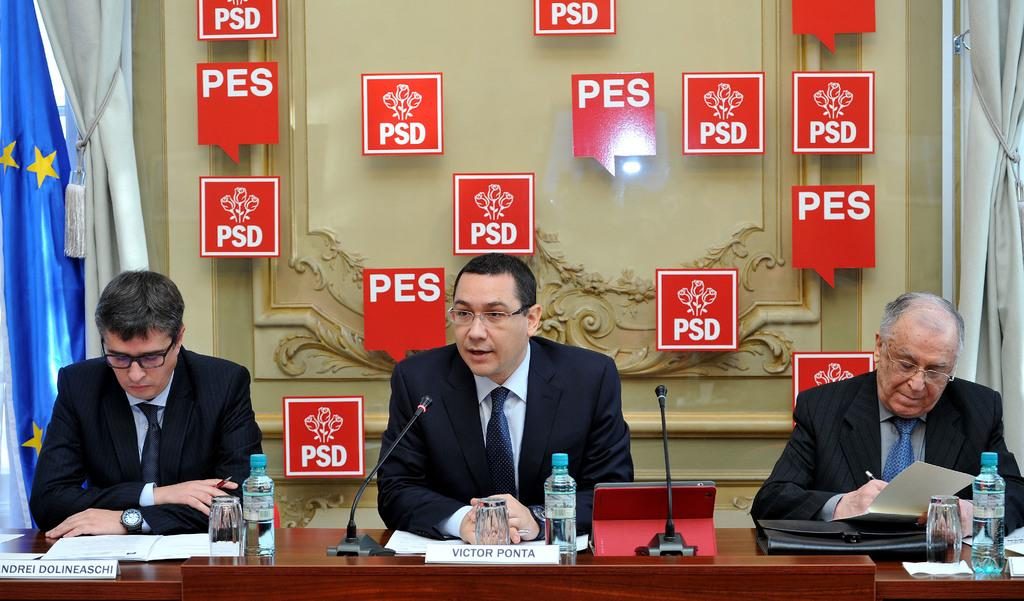<image>
Render a clear and concise summary of the photo. three men sitting in front of a wall with red signs that say 'pes' on some of them 